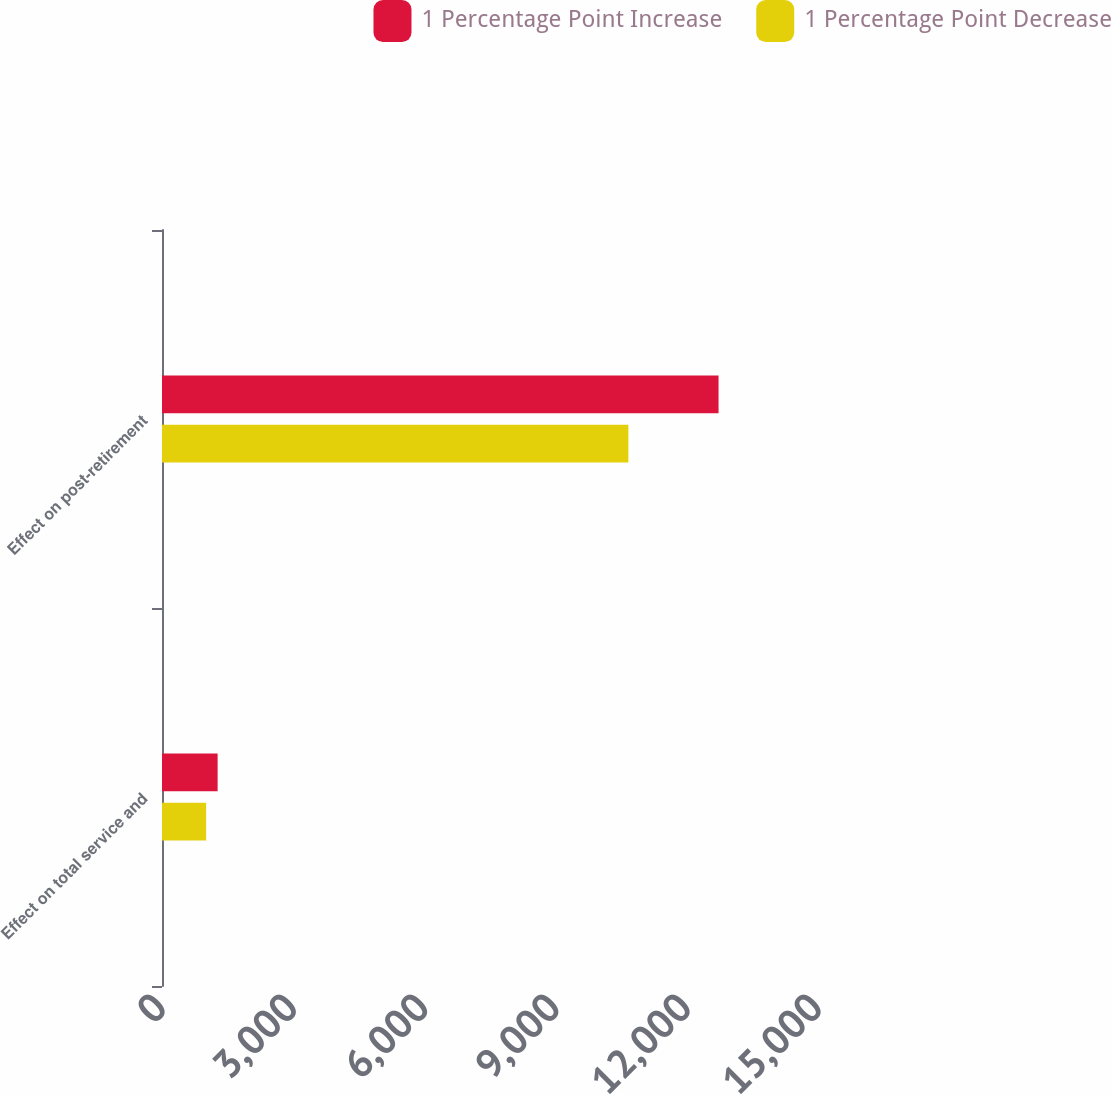Convert chart to OTSL. <chart><loc_0><loc_0><loc_500><loc_500><stacked_bar_chart><ecel><fcel>Effect on total service and<fcel>Effect on post-retirement<nl><fcel>1 Percentage Point Increase<fcel>1272<fcel>12726<nl><fcel>1 Percentage Point Decrease<fcel>1009<fcel>10664<nl></chart> 